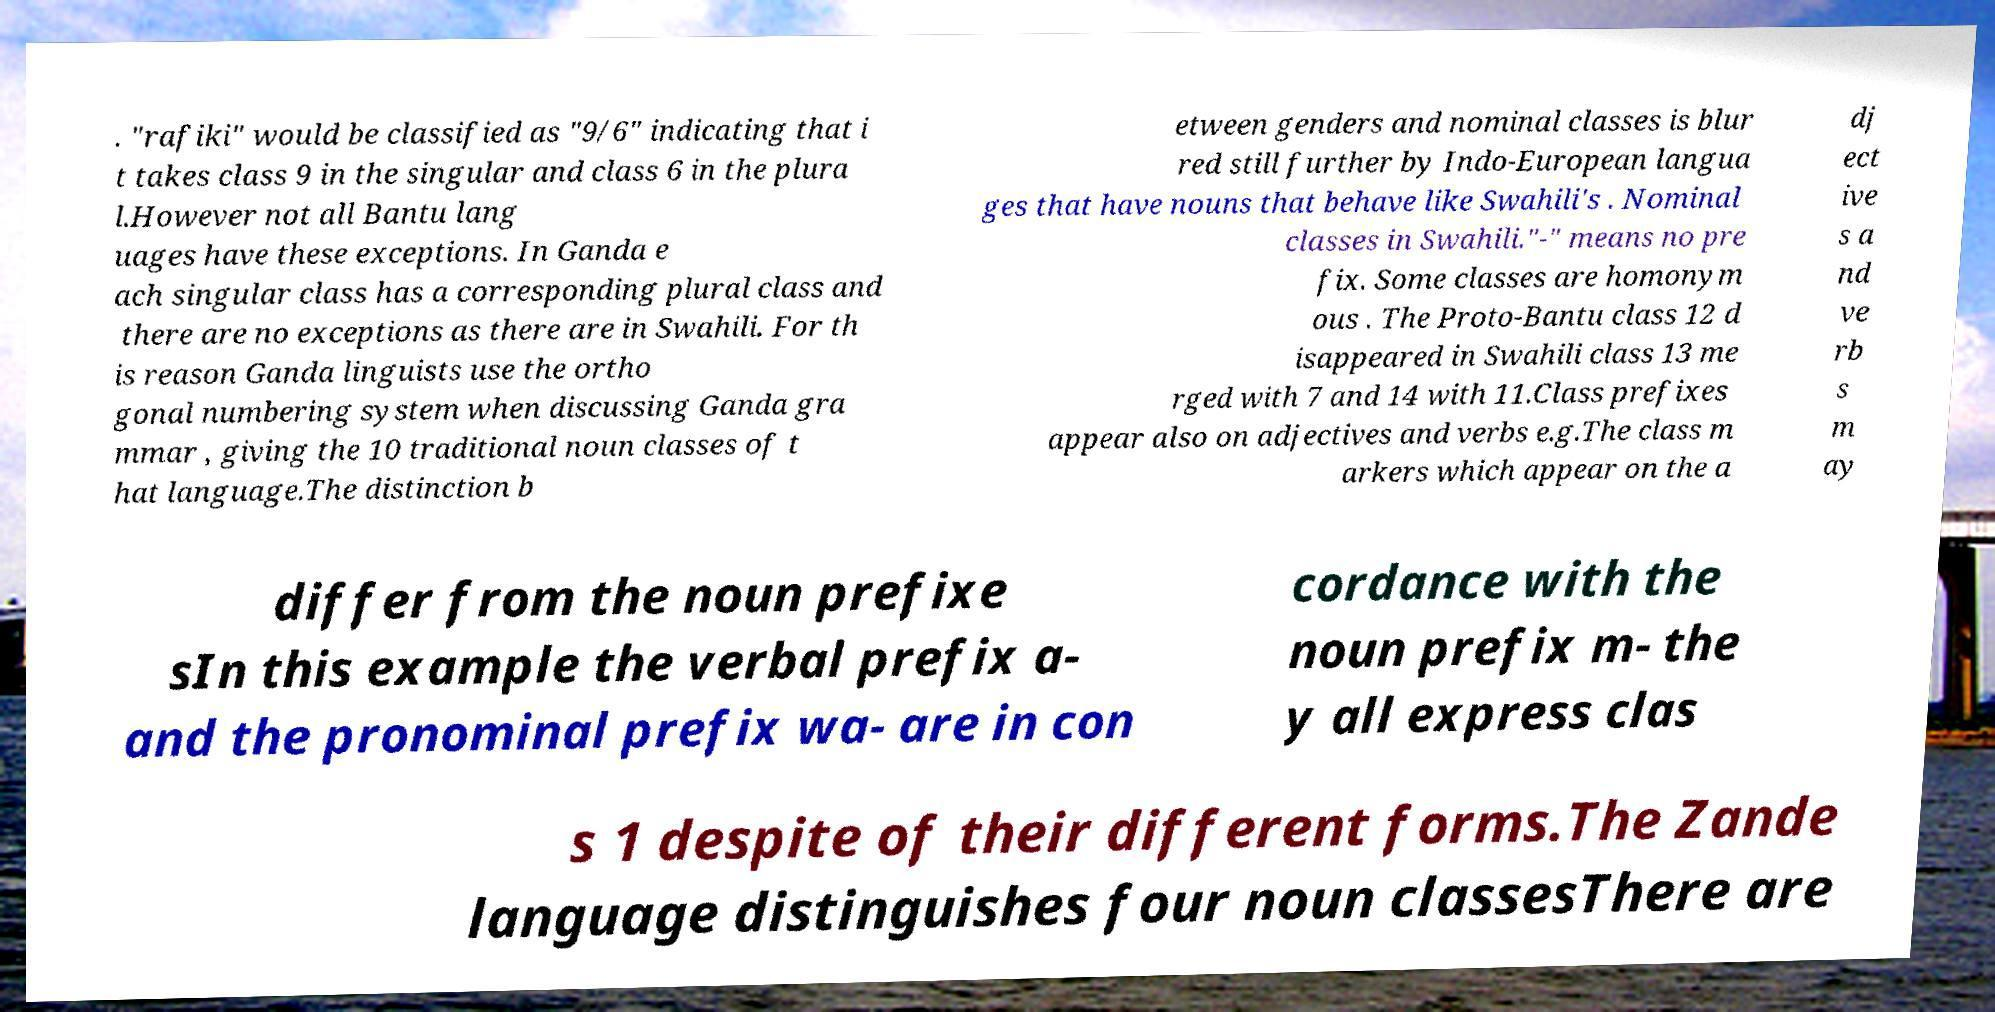I need the written content from this picture converted into text. Can you do that? . "rafiki" would be classified as "9/6" indicating that i t takes class 9 in the singular and class 6 in the plura l.However not all Bantu lang uages have these exceptions. In Ganda e ach singular class has a corresponding plural class and there are no exceptions as there are in Swahili. For th is reason Ganda linguists use the ortho gonal numbering system when discussing Ganda gra mmar , giving the 10 traditional noun classes of t hat language.The distinction b etween genders and nominal classes is blur red still further by Indo-European langua ges that have nouns that behave like Swahili's . Nominal classes in Swahili."-" means no pre fix. Some classes are homonym ous . The Proto-Bantu class 12 d isappeared in Swahili class 13 me rged with 7 and 14 with 11.Class prefixes appear also on adjectives and verbs e.g.The class m arkers which appear on the a dj ect ive s a nd ve rb s m ay differ from the noun prefixe sIn this example the verbal prefix a- and the pronominal prefix wa- are in con cordance with the noun prefix m- the y all express clas s 1 despite of their different forms.The Zande language distinguishes four noun classesThere are 